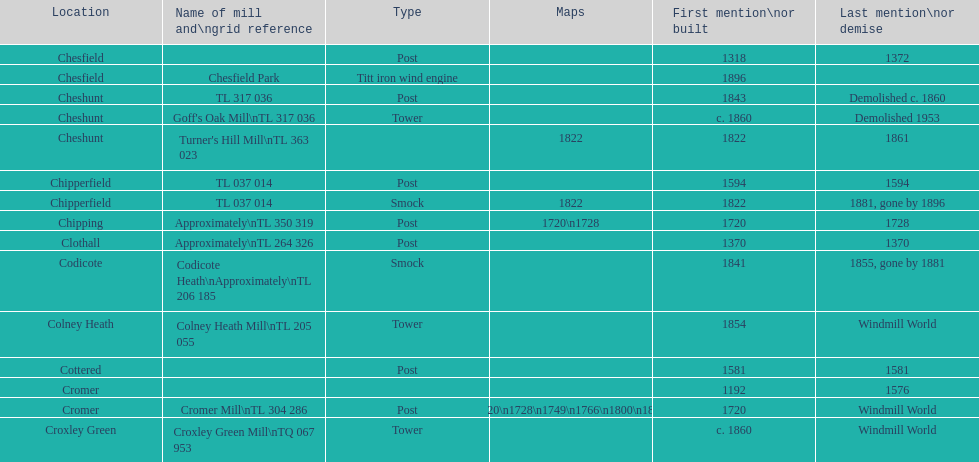In which location can the most maps be found? Cromer. 